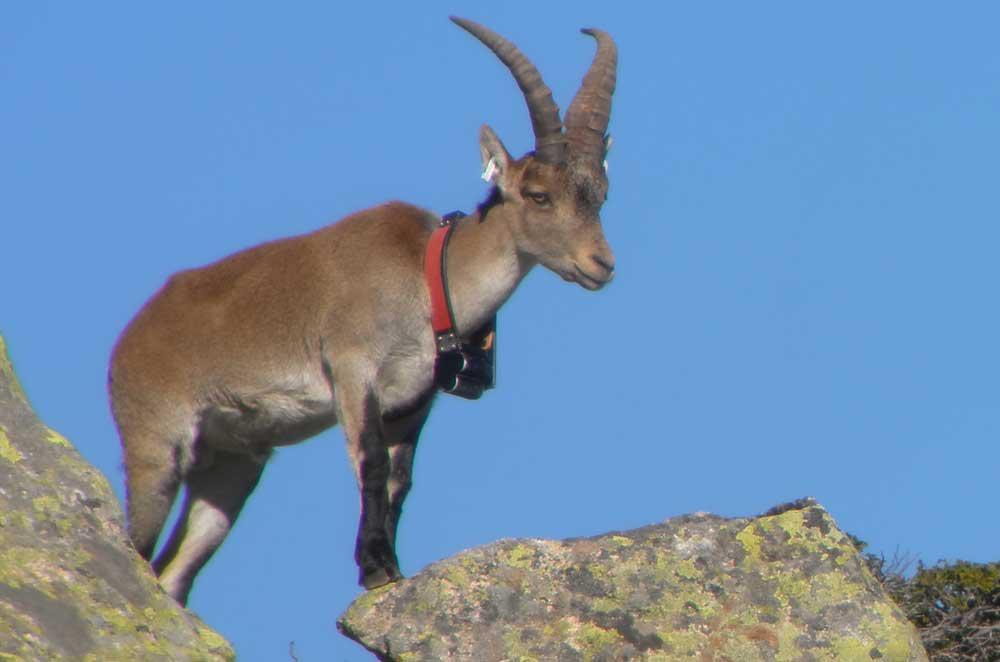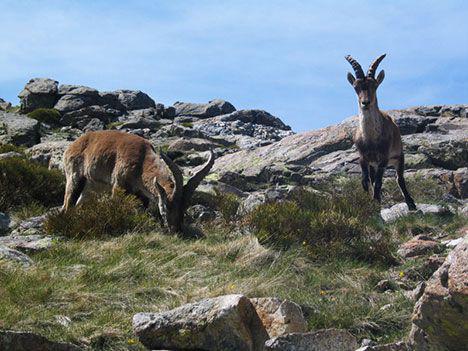The first image is the image on the left, the second image is the image on the right. Evaluate the accuracy of this statement regarding the images: "The animal in the image on the left is clearly standing atop a peak.". Is it true? Answer yes or no. Yes. 